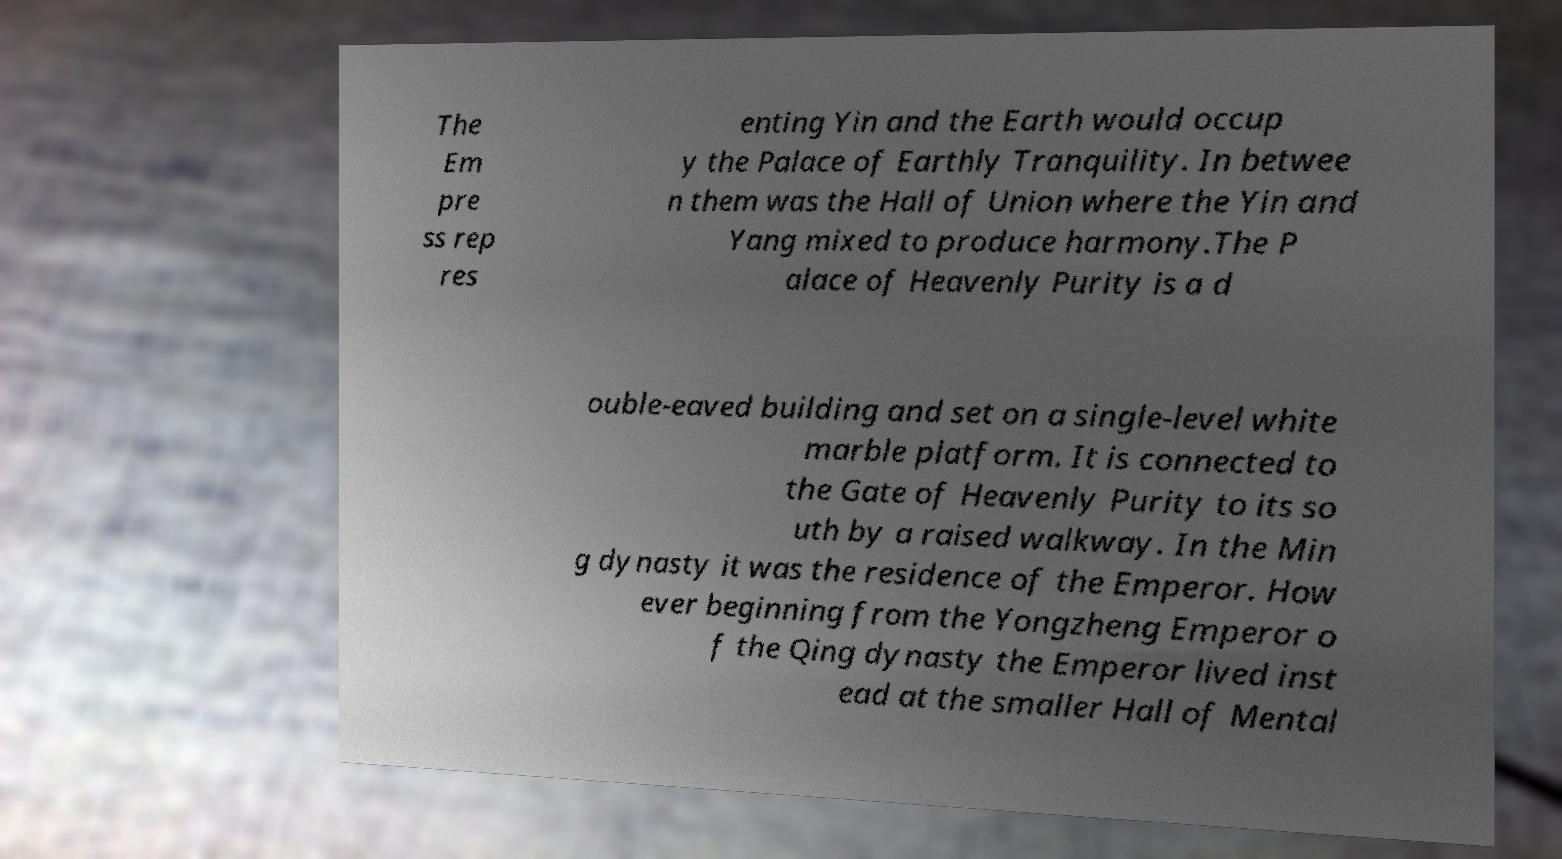Could you assist in decoding the text presented in this image and type it out clearly? The Em pre ss rep res enting Yin and the Earth would occup y the Palace of Earthly Tranquility. In betwee n them was the Hall of Union where the Yin and Yang mixed to produce harmony.The P alace of Heavenly Purity is a d ouble-eaved building and set on a single-level white marble platform. It is connected to the Gate of Heavenly Purity to its so uth by a raised walkway. In the Min g dynasty it was the residence of the Emperor. How ever beginning from the Yongzheng Emperor o f the Qing dynasty the Emperor lived inst ead at the smaller Hall of Mental 